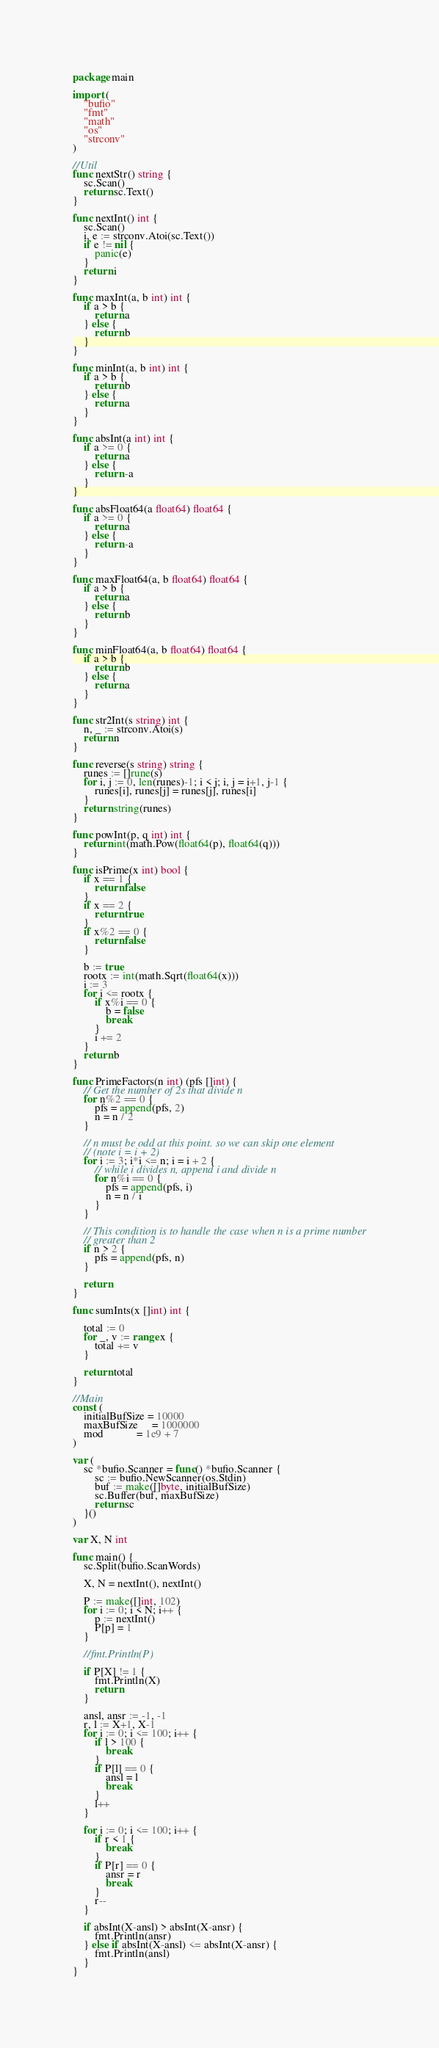Convert code to text. <code><loc_0><loc_0><loc_500><loc_500><_Go_>package main

import (
	"bufio"
	"fmt"
	"math"
	"os"
	"strconv"
)

//Util
func nextStr() string {
	sc.Scan()
	return sc.Text()
}

func nextInt() int {
	sc.Scan()
	i, e := strconv.Atoi(sc.Text())
	if e != nil {
		panic(e)
	}
	return i
}

func maxInt(a, b int) int {
	if a > b {
		return a
	} else {
		return b
	}
}

func minInt(a, b int) int {
	if a > b {
		return b
	} else {
		return a
	}
}

func absInt(a int) int {
	if a >= 0 {
		return a
	} else {
		return -a
	}
}

func absFloat64(a float64) float64 {
	if a >= 0 {
		return a
	} else {
		return -a
	}
}

func maxFloat64(a, b float64) float64 {
	if a > b {
		return a
	} else {
		return b
	}
}

func minFloat64(a, b float64) float64 {
	if a > b {
		return b
	} else {
		return a
	}
}

func str2Int(s string) int {
	n, _ := strconv.Atoi(s)
	return n
}

func reverse(s string) string {
	runes := []rune(s)
	for i, j := 0, len(runes)-1; i < j; i, j = i+1, j-1 {
		runes[i], runes[j] = runes[j], runes[i]
	}
	return string(runes)
}

func powInt(p, q int) int {
	return int(math.Pow(float64(p), float64(q)))
}

func isPrime(x int) bool {
	if x == 1 {
		return false
	}
	if x == 2 {
		return true
	}
	if x%2 == 0 {
		return false
	}

	b := true
	rootx := int(math.Sqrt(float64(x)))
	i := 3
	for i <= rootx {
		if x%i == 0 {
			b = false
			break
		}
		i += 2
	}
	return b
}

func PrimeFactors(n int) (pfs []int) {
	// Get the number of 2s that divide n
	for n%2 == 0 {
		pfs = append(pfs, 2)
		n = n / 2
	}

	// n must be odd at this point. so we can skip one element
	// (note i = i + 2)
	for i := 3; i*i <= n; i = i + 2 {
		// while i divides n, append i and divide n
		for n%i == 0 {
			pfs = append(pfs, i)
			n = n / i
		}
	}

	// This condition is to handle the case when n is a prime number
	// greater than 2
	if n > 2 {
		pfs = append(pfs, n)
	}

	return
}

func sumInts(x []int) int {

	total := 0
	for _, v := range x {
		total += v
	}

	return total
}

//Main
const (
	initialBufSize = 10000
	maxBufSize     = 1000000
	mod            = 1e9 + 7
)

var (
	sc *bufio.Scanner = func() *bufio.Scanner {
		sc := bufio.NewScanner(os.Stdin)
		buf := make([]byte, initialBufSize)
		sc.Buffer(buf, maxBufSize)
		return sc
	}()
)

var X, N int

func main() {
	sc.Split(bufio.ScanWords)

	X, N = nextInt(), nextInt()

	P := make([]int, 102)
	for i := 0; i < N; i++ {
		p := nextInt()
		P[p] = 1
	}

	//fmt.Println(P)

	if P[X] != 1 {
		fmt.Println(X)
		return
	}

	ansl, ansr := -1, -1
	r, l := X+1, X-1
	for i := 0; i <= 100; i++ {
		if l > 100 {
			break
		}
		if P[l] == 0 {
			ansl = l
			break
		}
		l++
	}

	for i := 0; i <= 100; i++ {
		if r < 1 {
			break
		}
		if P[r] == 0 {
			ansr = r
			break
		}
		r--
	}

	if absInt(X-ansl) > absInt(X-ansr) {
		fmt.Println(ansr)
	} else if absInt(X-ansl) <= absInt(X-ansr) {
		fmt.Println(ansl)
	}
}
</code> 